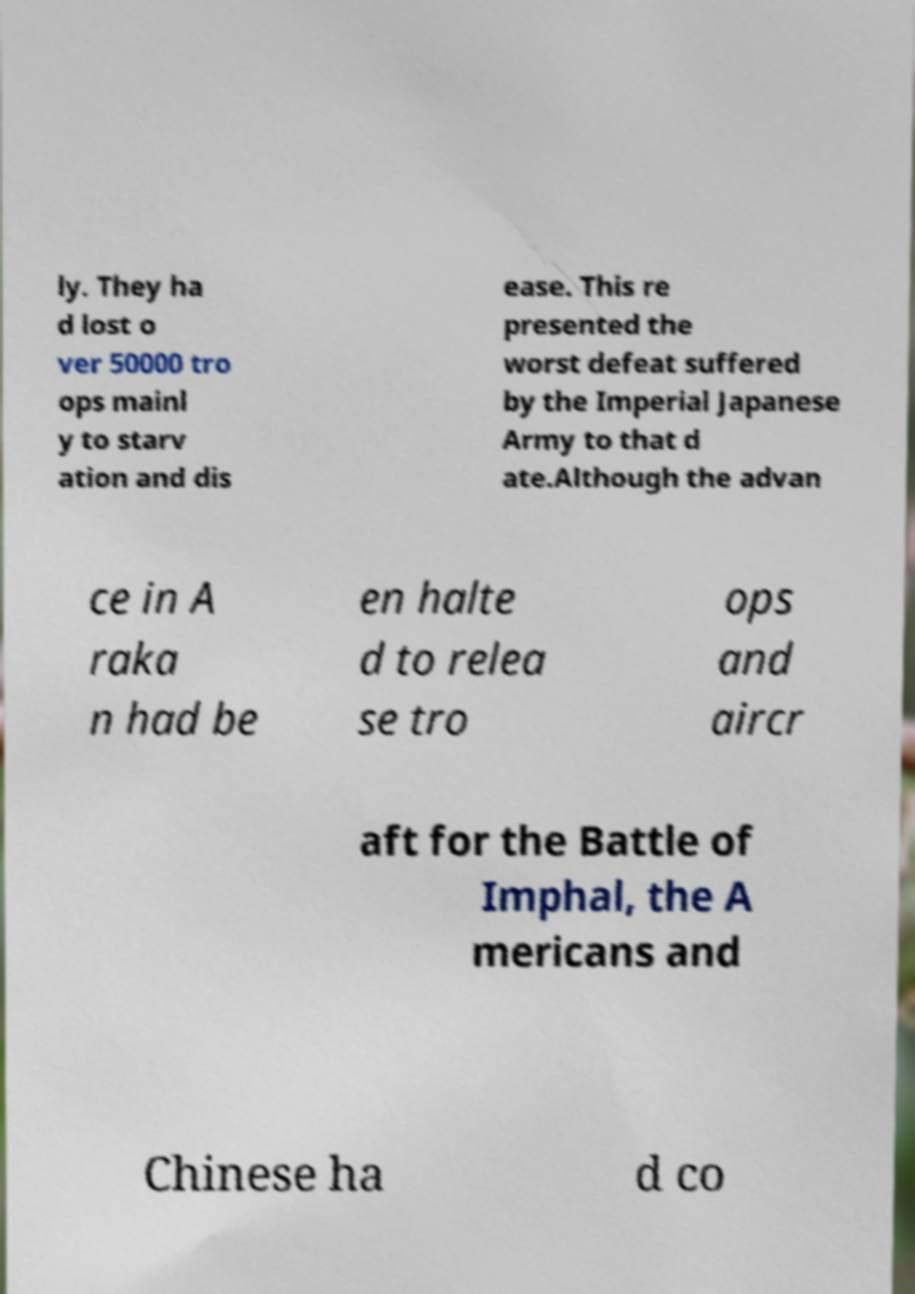Please read and relay the text visible in this image. What does it say? ly. They ha d lost o ver 50000 tro ops mainl y to starv ation and dis ease. This re presented the worst defeat suffered by the Imperial Japanese Army to that d ate.Although the advan ce in A raka n had be en halte d to relea se tro ops and aircr aft for the Battle of Imphal, the A mericans and Chinese ha d co 